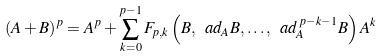Convert formula to latex. <formula><loc_0><loc_0><loc_500><loc_500>( A + B ) ^ { p } = A ^ { p } + \sum _ { k = 0 } ^ { p - 1 } F _ { p , k } \left ( B , \ a d _ { A } B , \dots , \ a d _ { A } ^ { \, p - k - 1 } B \right ) A ^ { k }</formula> 